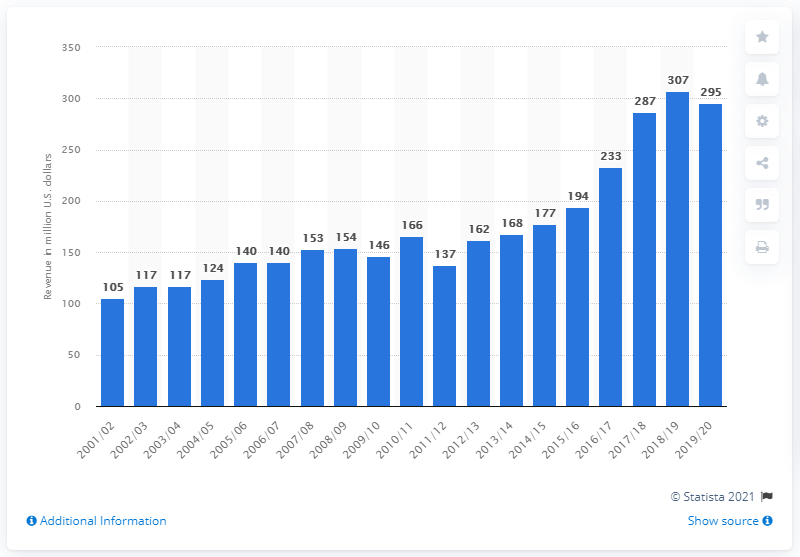Point out several critical features in this image. The Dallas Mavericks' first season was in 2001/2002. The estimated revenue of the Dallas Mavericks in the 2019/2020 season was approximately 295 million dollars. In the 2019/2020 season, the Dallas Mavericks franchise made a profit. 